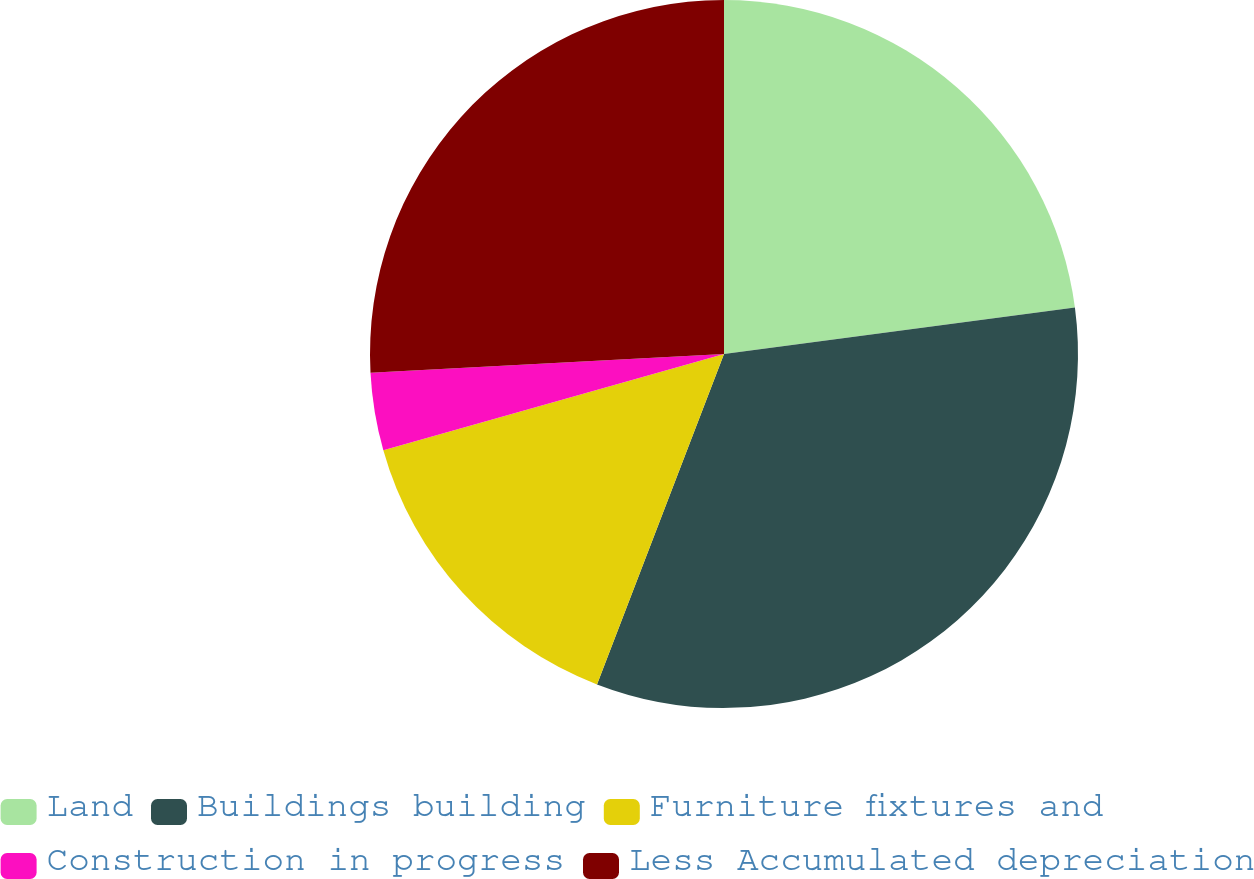<chart> <loc_0><loc_0><loc_500><loc_500><pie_chart><fcel>Land<fcel>Buildings building<fcel>Furniture fixtures and<fcel>Construction in progress<fcel>Less Accumulated depreciation<nl><fcel>22.9%<fcel>32.94%<fcel>14.78%<fcel>3.54%<fcel>25.84%<nl></chart> 